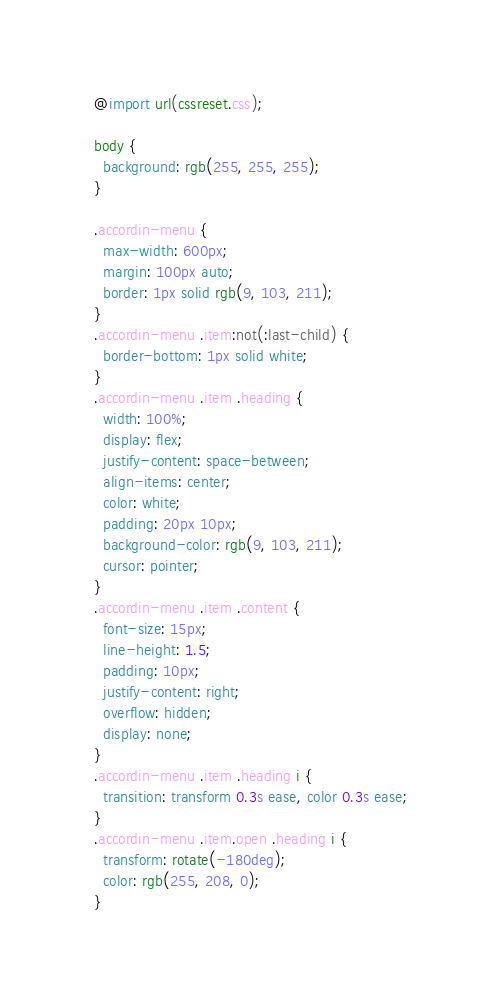Convert code to text. <code><loc_0><loc_0><loc_500><loc_500><_CSS_>@import url(cssreset.css);

body {
  background: rgb(255, 255, 255);
}

.accordin-menu {
  max-width: 600px;
  margin: 100px auto;
  border: 1px solid rgb(9, 103, 211);
}
.accordin-menu .item:not(:last-child) {
  border-bottom: 1px solid white;
}
.accordin-menu .item .heading {
  width: 100%;
  display: flex;
  justify-content: space-between;
  align-items: center;
  color: white;
  padding: 20px 10px;
  background-color: rgb(9, 103, 211);
  cursor: pointer;
}
.accordin-menu .item .content {
  font-size: 15px;
  line-height: 1.5;
  padding: 10px;
  justify-content: right;
  overflow: hidden;
  display: none;
}
.accordin-menu .item .heading i {
  transition: transform 0.3s ease, color 0.3s ease;
}
.accordin-menu .item.open .heading i {
  transform: rotate(-180deg);
  color: rgb(255, 208, 0);
}
</code> 